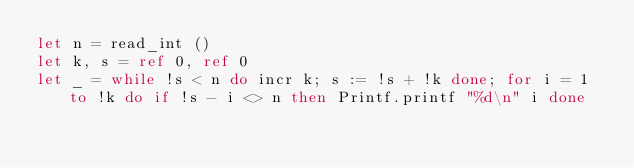Convert code to text. <code><loc_0><loc_0><loc_500><loc_500><_OCaml_>let n = read_int ()
let k, s = ref 0, ref 0
let _ = while !s < n do incr k; s := !s + !k done; for i = 1 to !k do if !s - i <> n then Printf.printf "%d\n" i done</code> 